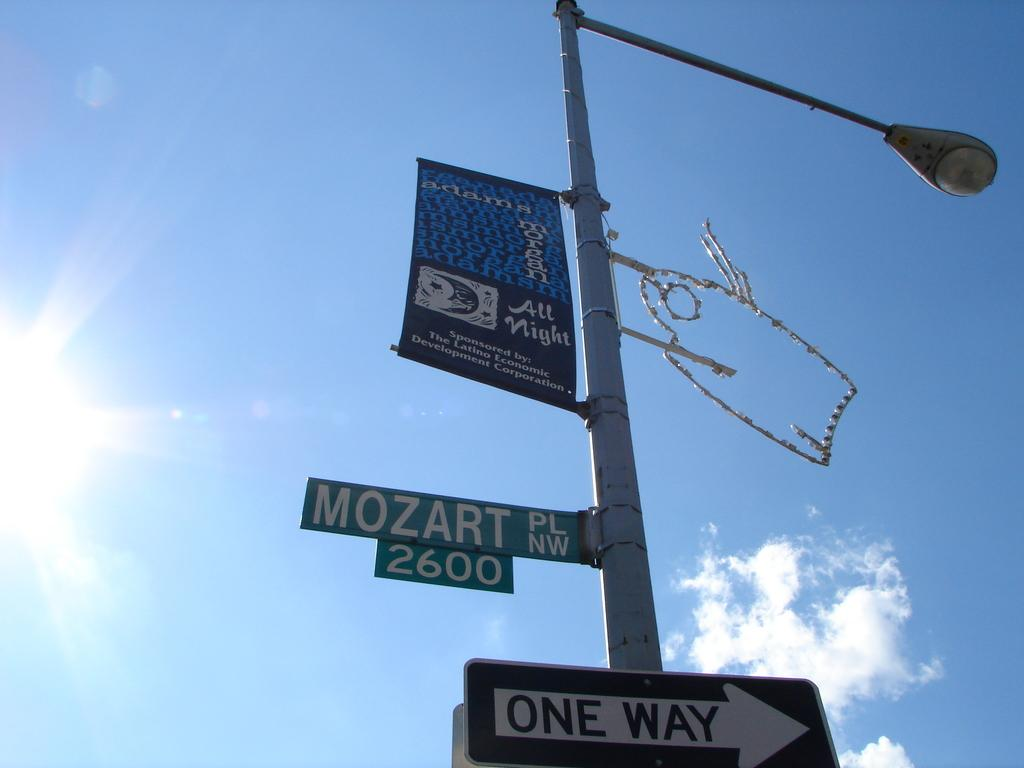What is the main object in the image? There is a street light in the image. What is attached to the street light? Banners and sign boards are attached to the street light. What can be seen in the background of the image? The background of the image includes the sky. Can you see a receipt attached to the street light in the image? No, there is no receipt present in the image. 